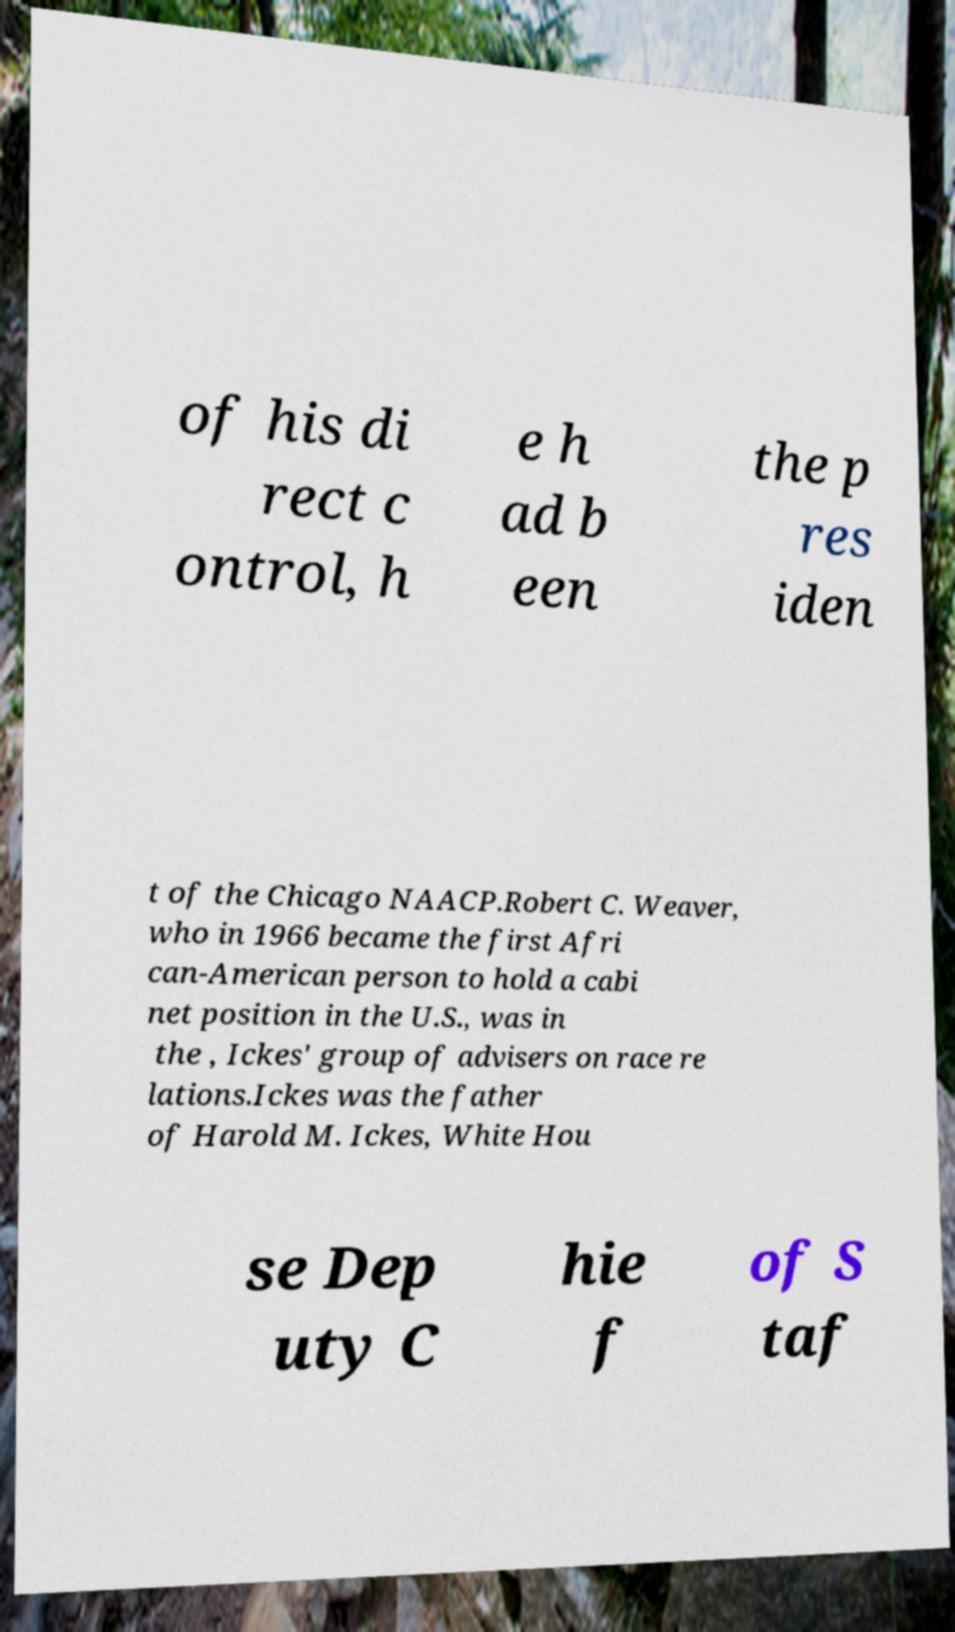For documentation purposes, I need the text within this image transcribed. Could you provide that? of his di rect c ontrol, h e h ad b een the p res iden t of the Chicago NAACP.Robert C. Weaver, who in 1966 became the first Afri can-American person to hold a cabi net position in the U.S., was in the , Ickes' group of advisers on race re lations.Ickes was the father of Harold M. Ickes, White Hou se Dep uty C hie f of S taf 